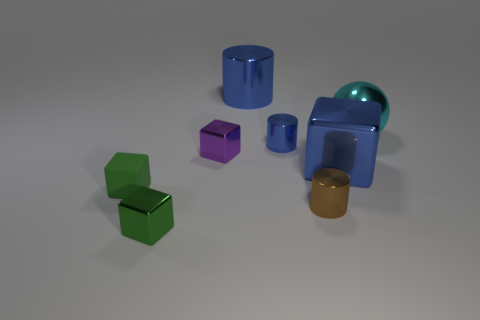How many large blue spheres have the same material as the small purple object?
Your answer should be very brief. 0. There is a metallic object that is behind the cyan metal ball; does it have the same size as the brown metal cylinder?
Offer a very short reply. No. There is a metal cylinder that is the same size as the cyan ball; what color is it?
Give a very brief answer. Blue. There is a small brown metallic cylinder; what number of tiny green things are in front of it?
Offer a terse response. 1. Are any purple blocks visible?
Keep it short and to the point. Yes. What is the size of the object to the left of the green object in front of the green block behind the tiny green metallic thing?
Keep it short and to the point. Small. What number of other objects are the same size as the cyan shiny thing?
Ensure brevity in your answer.  2. What is the size of the cylinder in front of the small blue object?
Your answer should be compact. Small. Are there any other things of the same color as the big cube?
Your answer should be compact. Yes. Are the small green cube that is behind the brown object and the brown thing made of the same material?
Your response must be concise. No. 